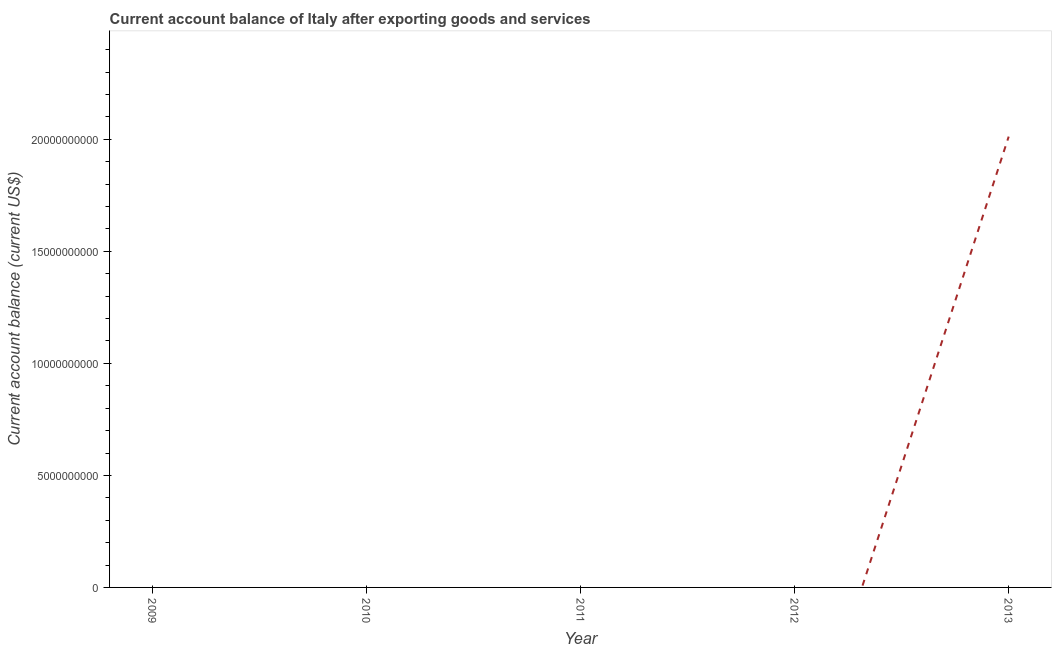What is the current account balance in 2013?
Your answer should be very brief. 2.01e+1. Across all years, what is the maximum current account balance?
Your response must be concise. 2.01e+1. In which year was the current account balance maximum?
Your answer should be very brief. 2013. What is the sum of the current account balance?
Make the answer very short. 2.01e+1. What is the average current account balance per year?
Keep it short and to the point. 4.02e+09. In how many years, is the current account balance greater than 20000000000 US$?
Provide a succinct answer. 1. What is the difference between the highest and the lowest current account balance?
Make the answer very short. 2.01e+1. In how many years, is the current account balance greater than the average current account balance taken over all years?
Provide a short and direct response. 1. Does the current account balance monotonically increase over the years?
Make the answer very short. No. How many lines are there?
Make the answer very short. 1. What is the difference between two consecutive major ticks on the Y-axis?
Provide a succinct answer. 5.00e+09. Are the values on the major ticks of Y-axis written in scientific E-notation?
Provide a short and direct response. No. What is the title of the graph?
Give a very brief answer. Current account balance of Italy after exporting goods and services. What is the label or title of the X-axis?
Your response must be concise. Year. What is the label or title of the Y-axis?
Make the answer very short. Current account balance (current US$). What is the Current account balance (current US$) in 2010?
Offer a very short reply. 0. What is the Current account balance (current US$) of 2013?
Give a very brief answer. 2.01e+1. 